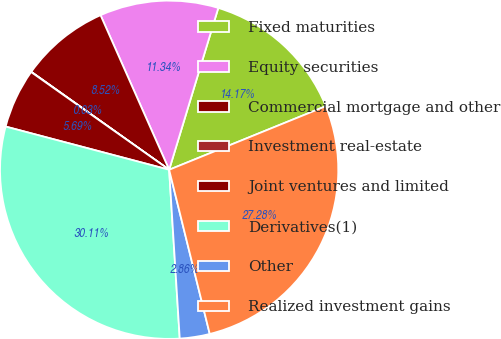Convert chart. <chart><loc_0><loc_0><loc_500><loc_500><pie_chart><fcel>Fixed maturities<fcel>Equity securities<fcel>Commercial mortgage and other<fcel>Investment real-estate<fcel>Joint ventures and limited<fcel>Derivatives(1)<fcel>Other<fcel>Realized investment gains<nl><fcel>14.17%<fcel>11.34%<fcel>8.52%<fcel>0.03%<fcel>5.69%<fcel>30.11%<fcel>2.86%<fcel>27.28%<nl></chart> 